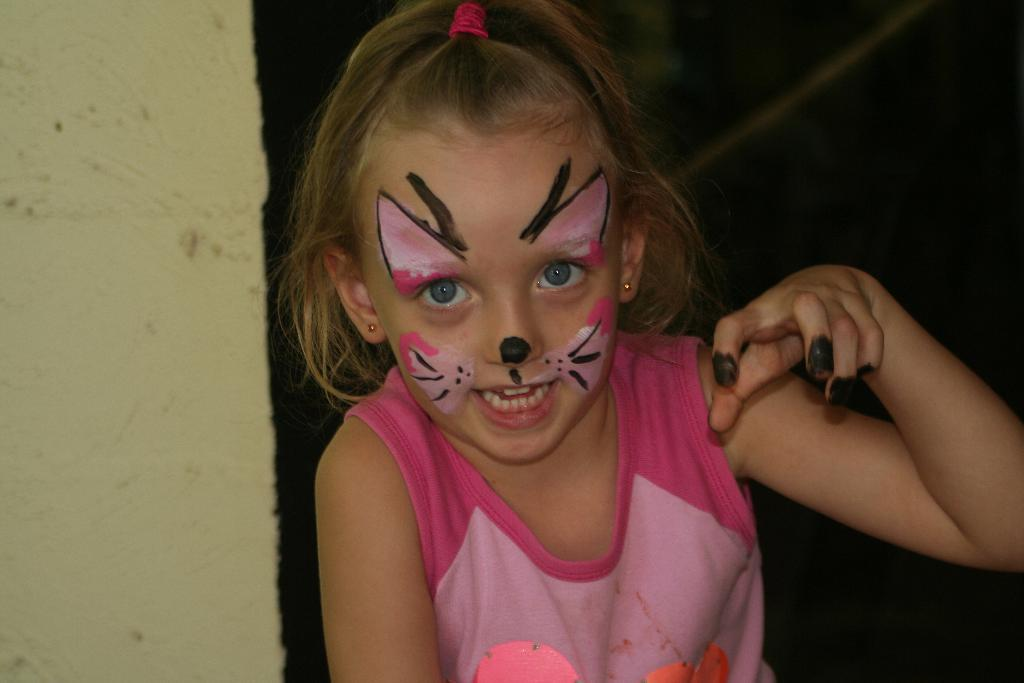Who is the main subject in the image? There is a girl in the image. Can you describe the girl's appearance? The girl is not wearing makeup. What can be seen in the background of the image? There is a wall in the background of the image. How would you describe the background's appearance? The background appears blurry. What type of circle can be seen in the image? There is no circle present in the image. What sense is being stimulated by the girl in the image? The image does not provide information about which sense is being stimulated by the girl. 